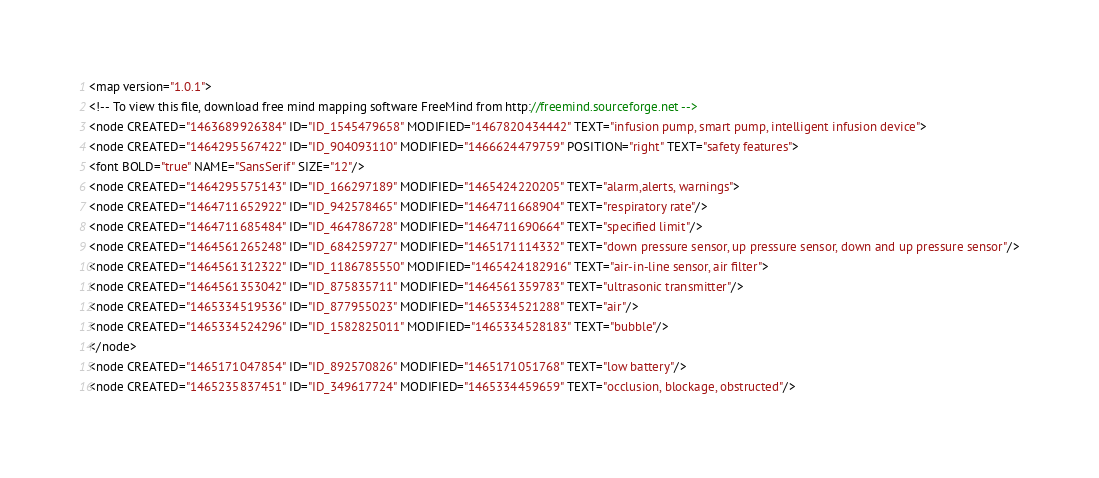Convert code to text. <code><loc_0><loc_0><loc_500><loc_500><_ObjectiveC_><map version="1.0.1">
<!-- To view this file, download free mind mapping software FreeMind from http://freemind.sourceforge.net -->
<node CREATED="1463689926384" ID="ID_1545479658" MODIFIED="1467820434442" TEXT="infusion pump, smart pump, intelligent infusion device">
<node CREATED="1464295567422" ID="ID_904093110" MODIFIED="1466624479759" POSITION="right" TEXT="safety features">
<font BOLD="true" NAME="SansSerif" SIZE="12"/>
<node CREATED="1464295575143" ID="ID_166297189" MODIFIED="1465424220205" TEXT="alarm,alerts, warnings">
<node CREATED="1464711652922" ID="ID_942578465" MODIFIED="1464711668904" TEXT="respiratory rate"/>
<node CREATED="1464711685484" ID="ID_464786728" MODIFIED="1464711690664" TEXT="specified limit"/>
<node CREATED="1464561265248" ID="ID_684259727" MODIFIED="1465171114332" TEXT="down pressure sensor, up pressure sensor, down and up pressure sensor"/>
<node CREATED="1464561312322" ID="ID_1186785550" MODIFIED="1465424182916" TEXT="air-in-line sensor, air filter">
<node CREATED="1464561353042" ID="ID_875835711" MODIFIED="1464561359783" TEXT="ultrasonic transmitter"/>
<node CREATED="1465334519536" ID="ID_877955023" MODIFIED="1465334521288" TEXT="air"/>
<node CREATED="1465334524296" ID="ID_1582825011" MODIFIED="1465334528183" TEXT="bubble"/>
</node>
<node CREATED="1465171047854" ID="ID_892570826" MODIFIED="1465171051768" TEXT="low battery"/>
<node CREATED="1465235837451" ID="ID_349617724" MODIFIED="1465334459659" TEXT="occlusion, blockage, obstructed"/></code> 